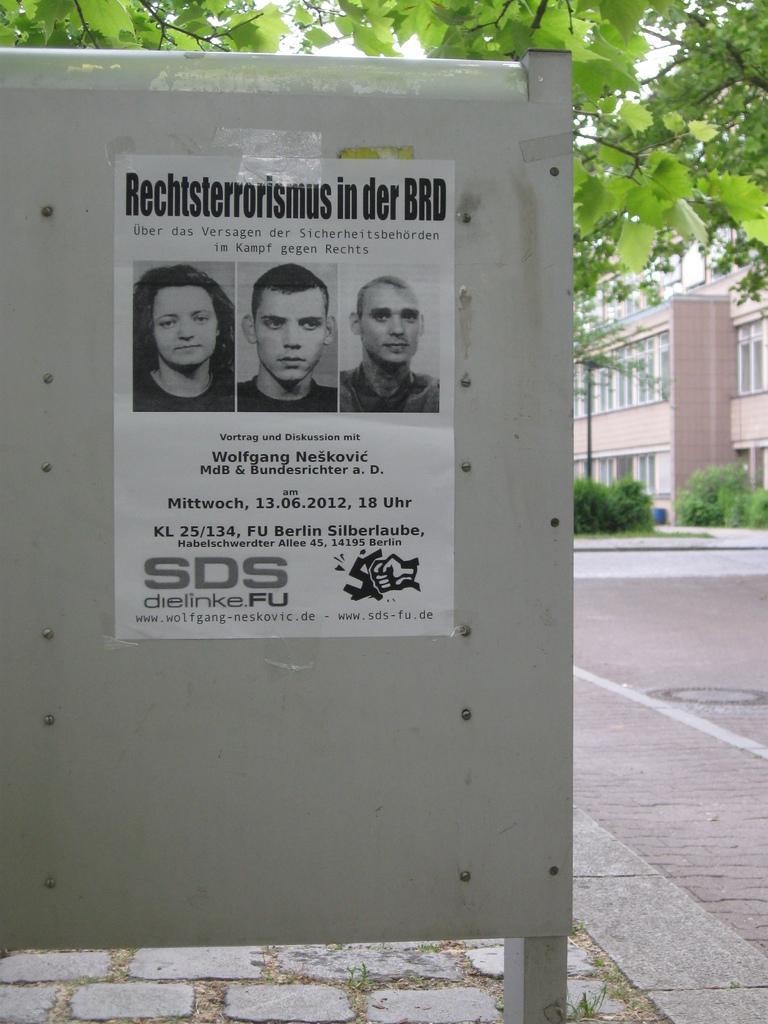In one or two sentences, can you explain what this image depicts? In this picture there is a iron board with a poster of three persons stick on it. Behind there is a brown color building and green tree. 